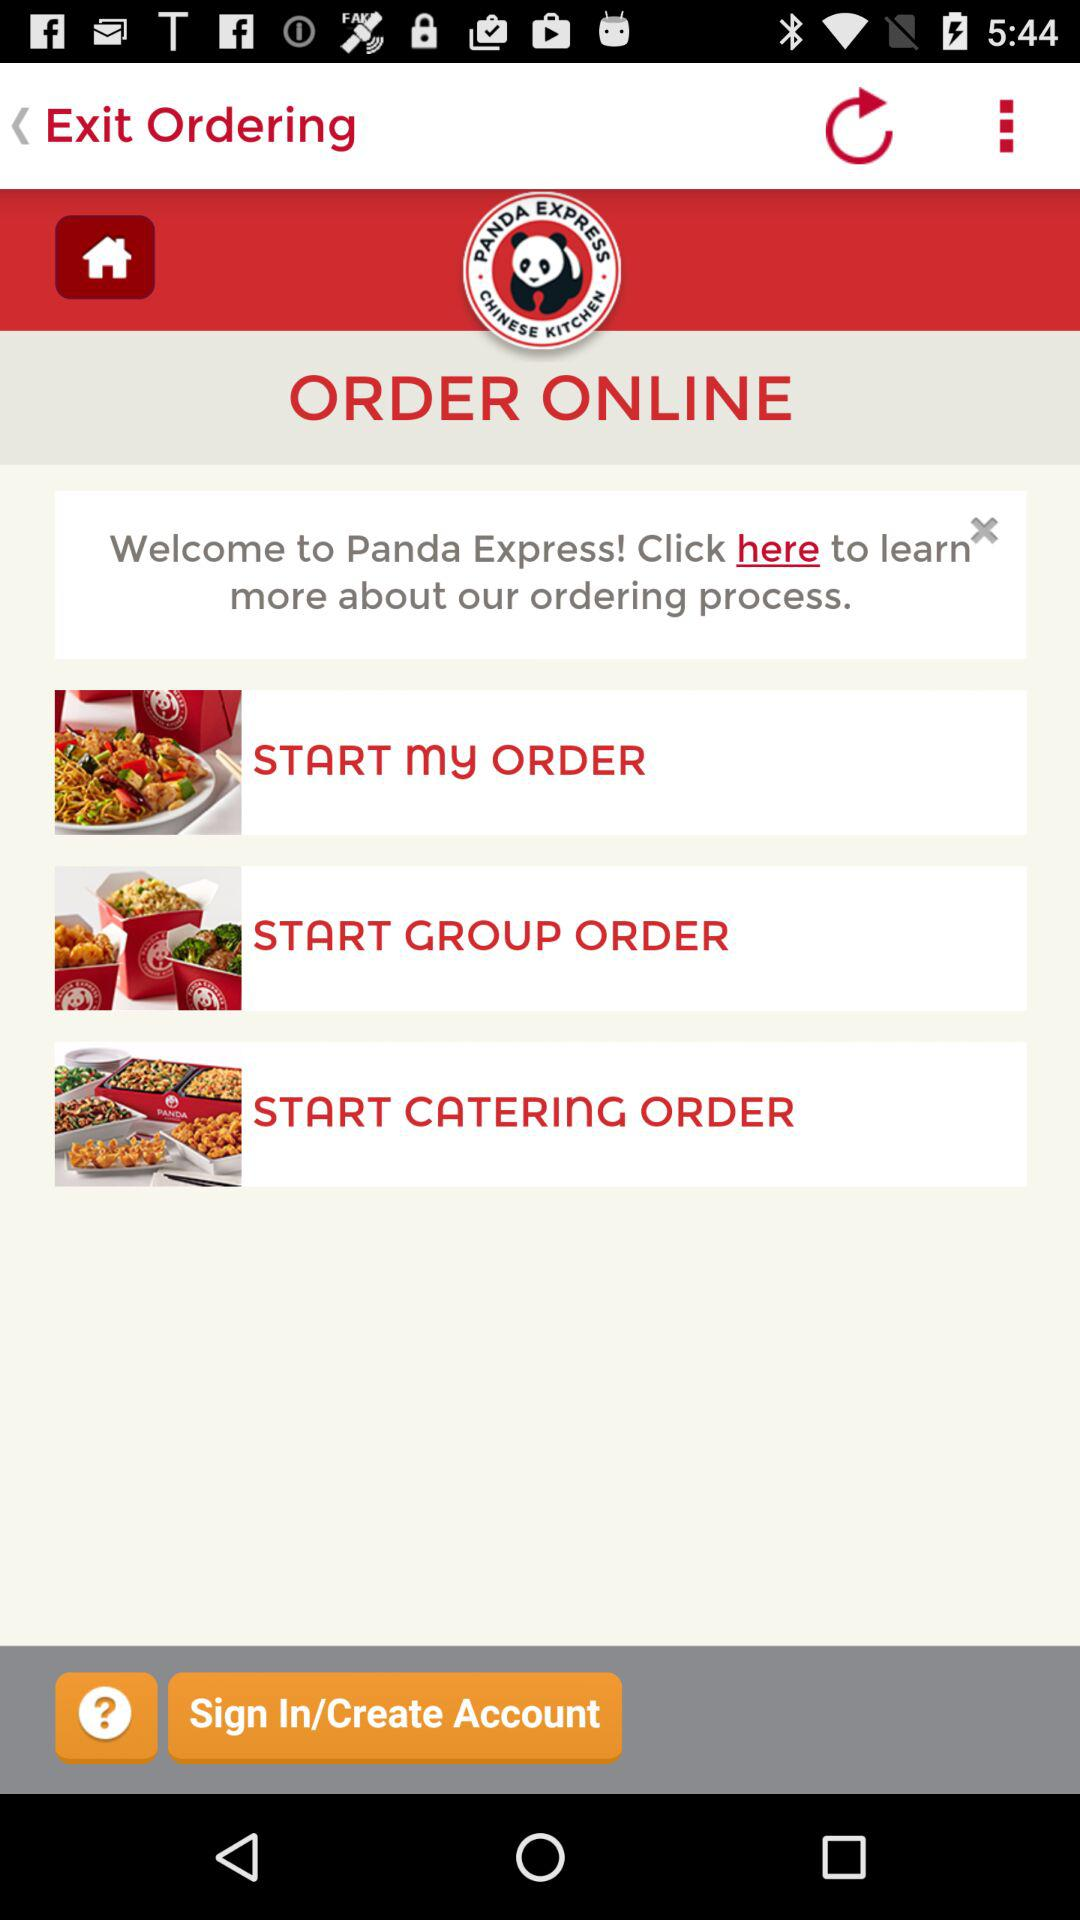What is the application name? The application name is "Panda Express". 